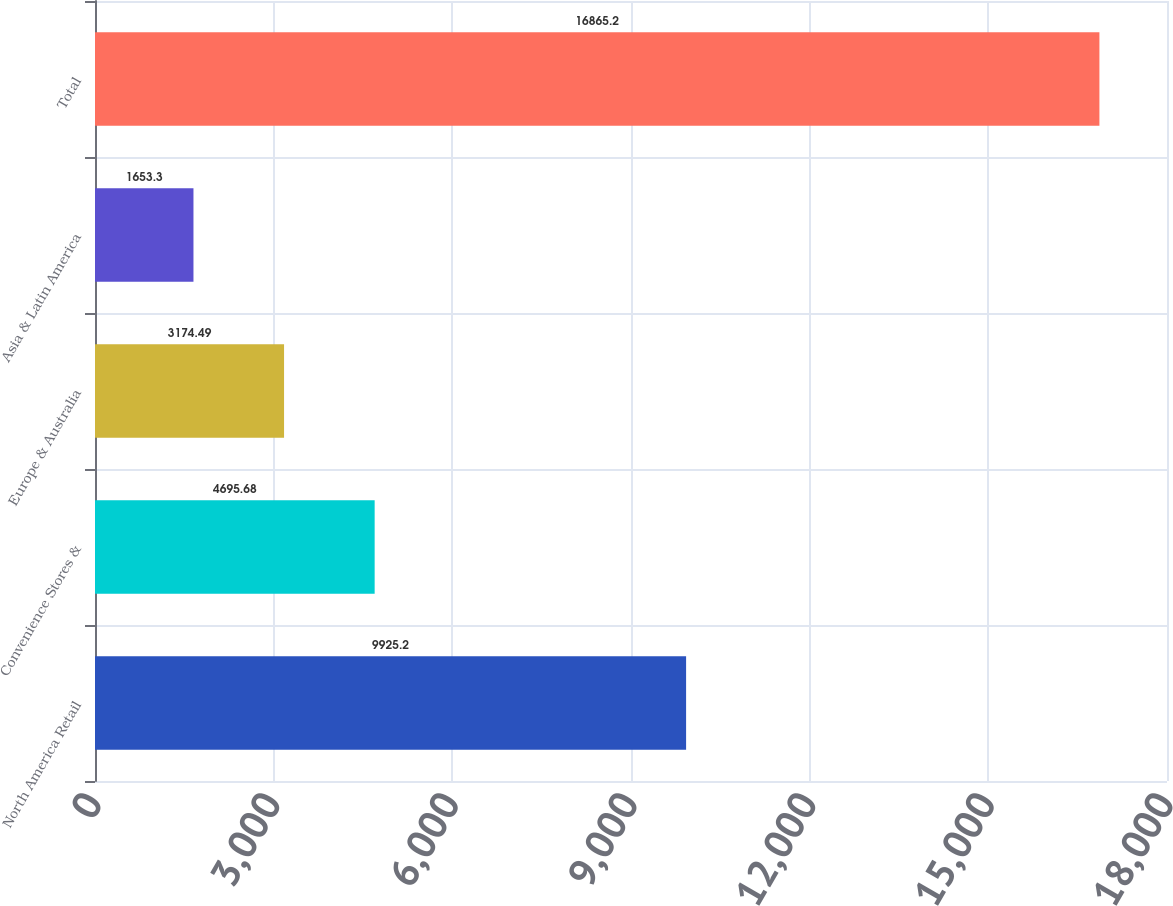Convert chart. <chart><loc_0><loc_0><loc_500><loc_500><bar_chart><fcel>North America Retail<fcel>Convenience Stores &<fcel>Europe & Australia<fcel>Asia & Latin America<fcel>Total<nl><fcel>9925.2<fcel>4695.68<fcel>3174.49<fcel>1653.3<fcel>16865.2<nl></chart> 